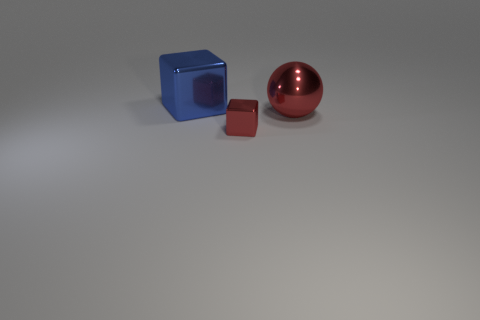Is the big object on the right side of the big blue metallic cube made of the same material as the tiny block?
Your answer should be very brief. Yes. There is a thing that is behind the large object that is on the right side of the tiny block; what number of large blue objects are in front of it?
Provide a short and direct response. 0. How big is the metallic sphere?
Your response must be concise. Large. Is the color of the small metallic cube the same as the shiny sphere?
Your response must be concise. Yes. How big is the metallic cube that is in front of the large blue block?
Offer a terse response. Small. There is a metal cube that is on the right side of the big blue block; does it have the same color as the large metallic object to the right of the big blue object?
Offer a very short reply. Yes. What number of other things are the same shape as the tiny red thing?
Give a very brief answer. 1. Is the number of big blue blocks in front of the tiny cube the same as the number of small metal blocks that are on the right side of the big red shiny thing?
Ensure brevity in your answer.  Yes. Does the cube that is in front of the blue metallic thing have the same material as the big blue thing that is left of the metal sphere?
Make the answer very short. Yes. How many other things are there of the same size as the blue object?
Ensure brevity in your answer.  1. 